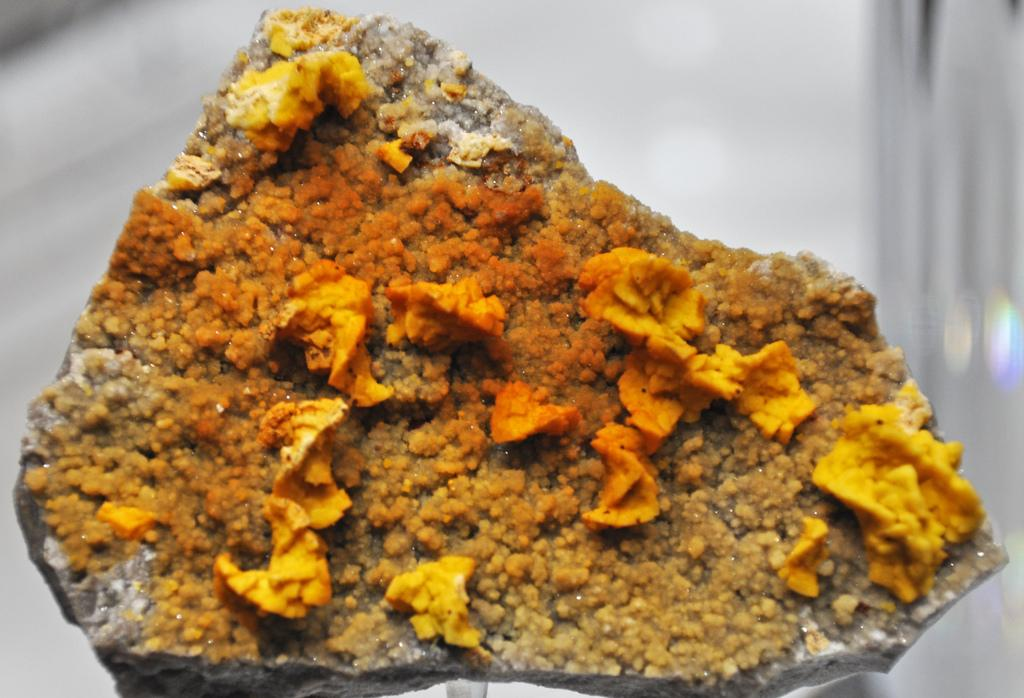What is the main subject of the image? There is a food item in the image. What color is the background of the image? The background of the image is white. What type of pies can be seen in the aftermath of the spring season in the image? There is no reference to pies, aftermath, or spring season in the image, so it's not possible to answer that question. 